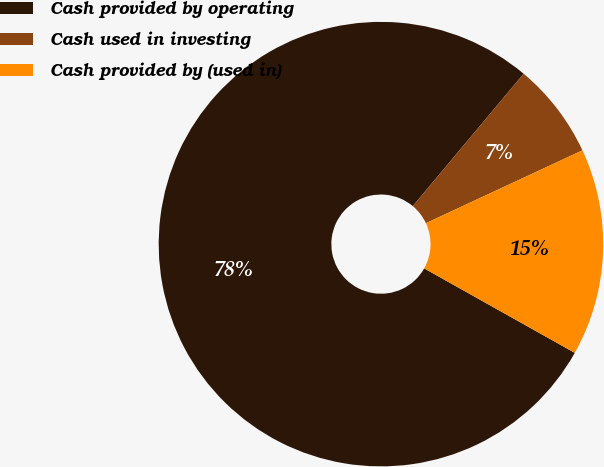<chart> <loc_0><loc_0><loc_500><loc_500><pie_chart><fcel>Cash provided by operating<fcel>Cash used in investing<fcel>Cash provided by (used in)<nl><fcel>77.96%<fcel>6.97%<fcel>15.07%<nl></chart> 